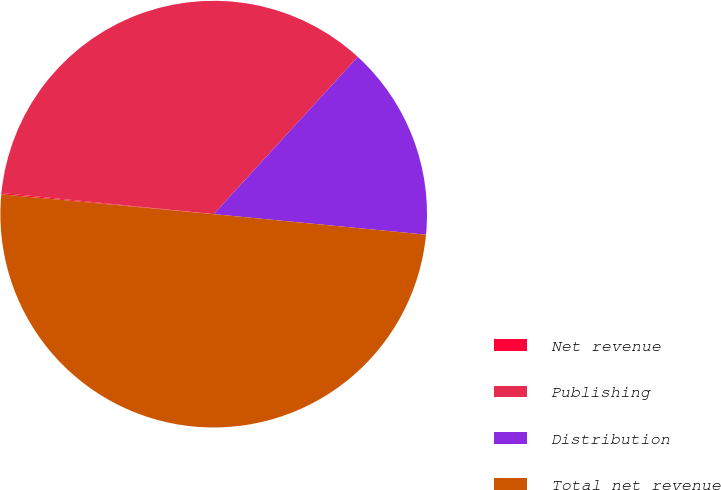Convert chart. <chart><loc_0><loc_0><loc_500><loc_500><pie_chart><fcel>Net revenue<fcel>Publishing<fcel>Distribution<fcel>Total net revenue<nl><fcel>0.1%<fcel>35.22%<fcel>14.73%<fcel>49.95%<nl></chart> 